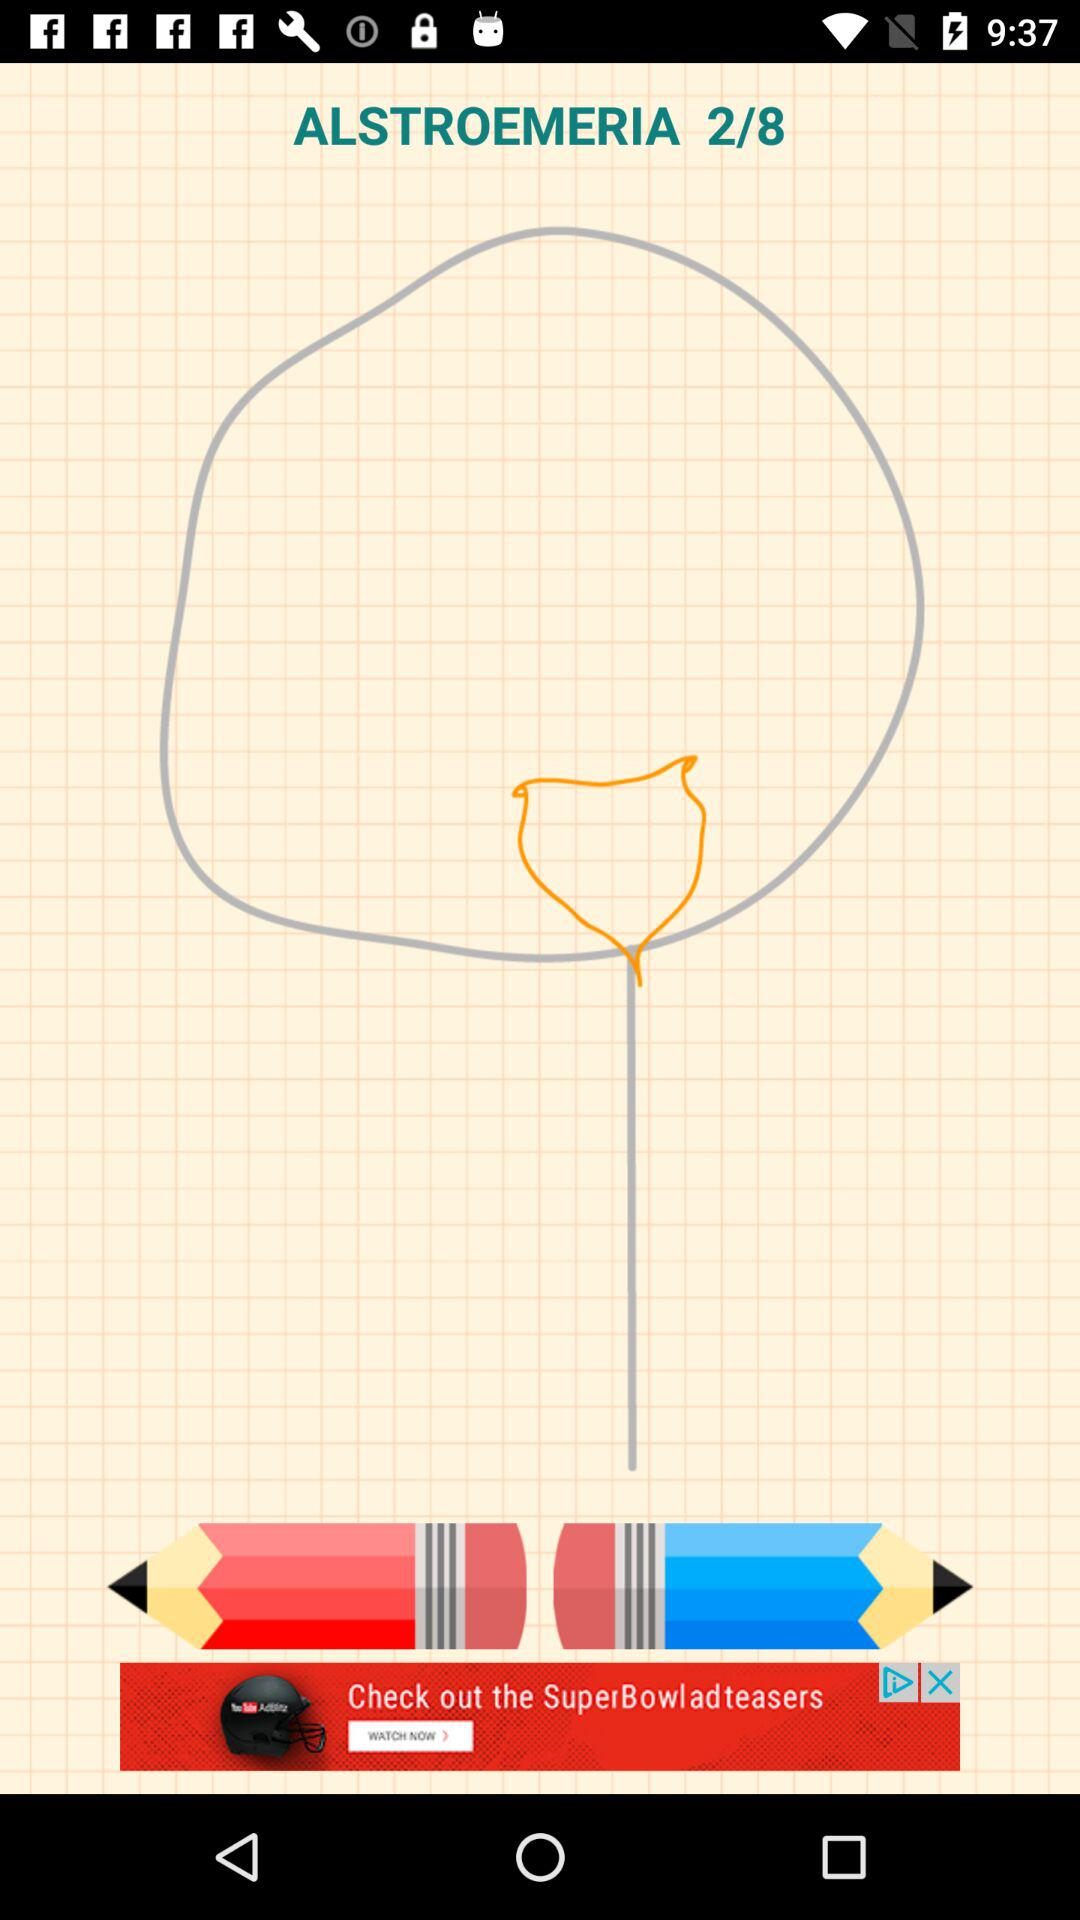What page are people currently at? The people are currently at page 2. 